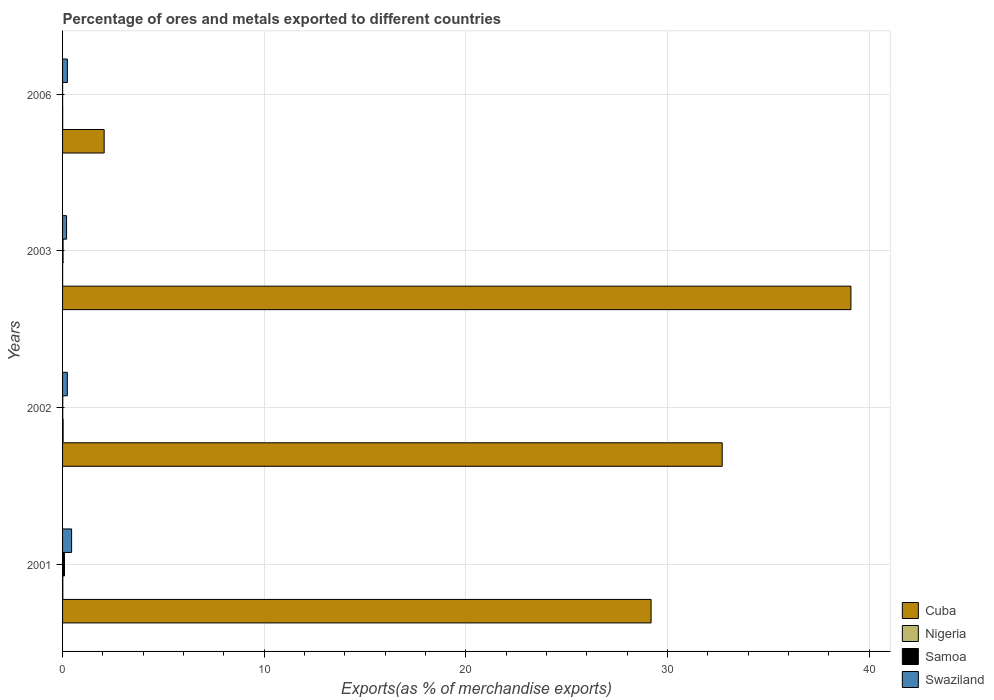How many different coloured bars are there?
Provide a succinct answer. 4. Are the number of bars per tick equal to the number of legend labels?
Your response must be concise. Yes. Are the number of bars on each tick of the Y-axis equal?
Keep it short and to the point. Yes. How many bars are there on the 3rd tick from the top?
Offer a terse response. 4. How many bars are there on the 4th tick from the bottom?
Your answer should be compact. 4. In how many cases, is the number of bars for a given year not equal to the number of legend labels?
Offer a very short reply. 0. What is the percentage of exports to different countries in Cuba in 2006?
Make the answer very short. 2.06. Across all years, what is the maximum percentage of exports to different countries in Nigeria?
Make the answer very short. 0.03. Across all years, what is the minimum percentage of exports to different countries in Nigeria?
Provide a succinct answer. 0. In which year was the percentage of exports to different countries in Nigeria minimum?
Your answer should be compact. 2003. What is the total percentage of exports to different countries in Samoa in the graph?
Make the answer very short. 0.13. What is the difference between the percentage of exports to different countries in Samoa in 2003 and that in 2006?
Offer a very short reply. 0.02. What is the difference between the percentage of exports to different countries in Cuba in 2003 and the percentage of exports to different countries in Samoa in 2002?
Keep it short and to the point. 39.08. What is the average percentage of exports to different countries in Nigeria per year?
Offer a terse response. 0.01. In the year 2006, what is the difference between the percentage of exports to different countries in Swaziland and percentage of exports to different countries in Cuba?
Ensure brevity in your answer.  -1.82. What is the ratio of the percentage of exports to different countries in Cuba in 2001 to that in 2003?
Your answer should be very brief. 0.75. What is the difference between the highest and the second highest percentage of exports to different countries in Swaziland?
Ensure brevity in your answer.  0.21. What is the difference between the highest and the lowest percentage of exports to different countries in Cuba?
Provide a succinct answer. 37.03. In how many years, is the percentage of exports to different countries in Nigeria greater than the average percentage of exports to different countries in Nigeria taken over all years?
Provide a succinct answer. 2. What does the 2nd bar from the top in 2001 represents?
Keep it short and to the point. Samoa. What does the 1st bar from the bottom in 2003 represents?
Your answer should be compact. Cuba. Are all the bars in the graph horizontal?
Your answer should be very brief. Yes. How many years are there in the graph?
Ensure brevity in your answer.  4. Where does the legend appear in the graph?
Your answer should be very brief. Bottom right. How many legend labels are there?
Ensure brevity in your answer.  4. What is the title of the graph?
Give a very brief answer. Percentage of ores and metals exported to different countries. What is the label or title of the X-axis?
Your response must be concise. Exports(as % of merchandise exports). What is the Exports(as % of merchandise exports) in Cuba in 2001?
Ensure brevity in your answer.  29.18. What is the Exports(as % of merchandise exports) in Nigeria in 2001?
Your answer should be compact. 0.01. What is the Exports(as % of merchandise exports) in Samoa in 2001?
Offer a terse response. 0.1. What is the Exports(as % of merchandise exports) in Swaziland in 2001?
Make the answer very short. 0.45. What is the Exports(as % of merchandise exports) of Cuba in 2002?
Offer a very short reply. 32.71. What is the Exports(as % of merchandise exports) of Nigeria in 2002?
Provide a short and direct response. 0.03. What is the Exports(as % of merchandise exports) of Samoa in 2002?
Your response must be concise. 0.01. What is the Exports(as % of merchandise exports) of Swaziland in 2002?
Offer a very short reply. 0.24. What is the Exports(as % of merchandise exports) in Cuba in 2003?
Give a very brief answer. 39.09. What is the Exports(as % of merchandise exports) of Nigeria in 2003?
Your response must be concise. 0. What is the Exports(as % of merchandise exports) of Samoa in 2003?
Keep it short and to the point. 0.02. What is the Exports(as % of merchandise exports) of Swaziland in 2003?
Ensure brevity in your answer.  0.2. What is the Exports(as % of merchandise exports) in Cuba in 2006?
Your answer should be compact. 2.06. What is the Exports(as % of merchandise exports) in Nigeria in 2006?
Give a very brief answer. 0.01. What is the Exports(as % of merchandise exports) of Samoa in 2006?
Make the answer very short. 0. What is the Exports(as % of merchandise exports) of Swaziland in 2006?
Make the answer very short. 0.24. Across all years, what is the maximum Exports(as % of merchandise exports) of Cuba?
Make the answer very short. 39.09. Across all years, what is the maximum Exports(as % of merchandise exports) in Nigeria?
Make the answer very short. 0.03. Across all years, what is the maximum Exports(as % of merchandise exports) of Samoa?
Ensure brevity in your answer.  0.1. Across all years, what is the maximum Exports(as % of merchandise exports) in Swaziland?
Offer a very short reply. 0.45. Across all years, what is the minimum Exports(as % of merchandise exports) of Cuba?
Ensure brevity in your answer.  2.06. Across all years, what is the minimum Exports(as % of merchandise exports) of Nigeria?
Your response must be concise. 0. Across all years, what is the minimum Exports(as % of merchandise exports) in Samoa?
Give a very brief answer. 0. Across all years, what is the minimum Exports(as % of merchandise exports) in Swaziland?
Ensure brevity in your answer.  0.2. What is the total Exports(as % of merchandise exports) of Cuba in the graph?
Provide a succinct answer. 103.05. What is the total Exports(as % of merchandise exports) of Nigeria in the graph?
Your answer should be very brief. 0.05. What is the total Exports(as % of merchandise exports) in Samoa in the graph?
Offer a very short reply. 0.13. What is the total Exports(as % of merchandise exports) in Swaziland in the graph?
Offer a very short reply. 1.12. What is the difference between the Exports(as % of merchandise exports) of Cuba in 2001 and that in 2002?
Offer a terse response. -3.53. What is the difference between the Exports(as % of merchandise exports) in Nigeria in 2001 and that in 2002?
Your answer should be compact. -0.02. What is the difference between the Exports(as % of merchandise exports) in Samoa in 2001 and that in 2002?
Your answer should be compact. 0.09. What is the difference between the Exports(as % of merchandise exports) in Swaziland in 2001 and that in 2002?
Give a very brief answer. 0.21. What is the difference between the Exports(as % of merchandise exports) in Cuba in 2001 and that in 2003?
Offer a very short reply. -9.91. What is the difference between the Exports(as % of merchandise exports) in Nigeria in 2001 and that in 2003?
Give a very brief answer. 0.01. What is the difference between the Exports(as % of merchandise exports) in Samoa in 2001 and that in 2003?
Your response must be concise. 0.07. What is the difference between the Exports(as % of merchandise exports) in Swaziland in 2001 and that in 2003?
Offer a very short reply. 0.25. What is the difference between the Exports(as % of merchandise exports) of Cuba in 2001 and that in 2006?
Ensure brevity in your answer.  27.12. What is the difference between the Exports(as % of merchandise exports) in Nigeria in 2001 and that in 2006?
Make the answer very short. 0.01. What is the difference between the Exports(as % of merchandise exports) in Samoa in 2001 and that in 2006?
Ensure brevity in your answer.  0.09. What is the difference between the Exports(as % of merchandise exports) in Swaziland in 2001 and that in 2006?
Ensure brevity in your answer.  0.21. What is the difference between the Exports(as % of merchandise exports) in Cuba in 2002 and that in 2003?
Offer a terse response. -6.38. What is the difference between the Exports(as % of merchandise exports) of Nigeria in 2002 and that in 2003?
Your answer should be compact. 0.03. What is the difference between the Exports(as % of merchandise exports) of Samoa in 2002 and that in 2003?
Your answer should be compact. -0.02. What is the difference between the Exports(as % of merchandise exports) of Swaziland in 2002 and that in 2003?
Give a very brief answer. 0.04. What is the difference between the Exports(as % of merchandise exports) in Cuba in 2002 and that in 2006?
Provide a short and direct response. 30.65. What is the difference between the Exports(as % of merchandise exports) of Nigeria in 2002 and that in 2006?
Give a very brief answer. 0.02. What is the difference between the Exports(as % of merchandise exports) in Samoa in 2002 and that in 2006?
Your answer should be very brief. 0.01. What is the difference between the Exports(as % of merchandise exports) in Swaziland in 2002 and that in 2006?
Provide a succinct answer. -0. What is the difference between the Exports(as % of merchandise exports) of Cuba in 2003 and that in 2006?
Your answer should be very brief. 37.03. What is the difference between the Exports(as % of merchandise exports) of Nigeria in 2003 and that in 2006?
Make the answer very short. -0. What is the difference between the Exports(as % of merchandise exports) of Samoa in 2003 and that in 2006?
Your answer should be compact. 0.02. What is the difference between the Exports(as % of merchandise exports) in Swaziland in 2003 and that in 2006?
Provide a succinct answer. -0.04. What is the difference between the Exports(as % of merchandise exports) of Cuba in 2001 and the Exports(as % of merchandise exports) of Nigeria in 2002?
Your response must be concise. 29.15. What is the difference between the Exports(as % of merchandise exports) of Cuba in 2001 and the Exports(as % of merchandise exports) of Samoa in 2002?
Your response must be concise. 29.17. What is the difference between the Exports(as % of merchandise exports) of Cuba in 2001 and the Exports(as % of merchandise exports) of Swaziland in 2002?
Give a very brief answer. 28.95. What is the difference between the Exports(as % of merchandise exports) in Nigeria in 2001 and the Exports(as % of merchandise exports) in Samoa in 2002?
Provide a succinct answer. 0. What is the difference between the Exports(as % of merchandise exports) in Nigeria in 2001 and the Exports(as % of merchandise exports) in Swaziland in 2002?
Your answer should be very brief. -0.22. What is the difference between the Exports(as % of merchandise exports) in Samoa in 2001 and the Exports(as % of merchandise exports) in Swaziland in 2002?
Give a very brief answer. -0.14. What is the difference between the Exports(as % of merchandise exports) in Cuba in 2001 and the Exports(as % of merchandise exports) in Nigeria in 2003?
Offer a terse response. 29.18. What is the difference between the Exports(as % of merchandise exports) of Cuba in 2001 and the Exports(as % of merchandise exports) of Samoa in 2003?
Ensure brevity in your answer.  29.16. What is the difference between the Exports(as % of merchandise exports) of Cuba in 2001 and the Exports(as % of merchandise exports) of Swaziland in 2003?
Provide a succinct answer. 28.98. What is the difference between the Exports(as % of merchandise exports) of Nigeria in 2001 and the Exports(as % of merchandise exports) of Samoa in 2003?
Provide a succinct answer. -0.01. What is the difference between the Exports(as % of merchandise exports) in Nigeria in 2001 and the Exports(as % of merchandise exports) in Swaziland in 2003?
Offer a terse response. -0.19. What is the difference between the Exports(as % of merchandise exports) of Samoa in 2001 and the Exports(as % of merchandise exports) of Swaziland in 2003?
Offer a very short reply. -0.1. What is the difference between the Exports(as % of merchandise exports) in Cuba in 2001 and the Exports(as % of merchandise exports) in Nigeria in 2006?
Make the answer very short. 29.18. What is the difference between the Exports(as % of merchandise exports) in Cuba in 2001 and the Exports(as % of merchandise exports) in Samoa in 2006?
Your answer should be very brief. 29.18. What is the difference between the Exports(as % of merchandise exports) of Cuba in 2001 and the Exports(as % of merchandise exports) of Swaziland in 2006?
Give a very brief answer. 28.94. What is the difference between the Exports(as % of merchandise exports) in Nigeria in 2001 and the Exports(as % of merchandise exports) in Samoa in 2006?
Your answer should be very brief. 0.01. What is the difference between the Exports(as % of merchandise exports) in Nigeria in 2001 and the Exports(as % of merchandise exports) in Swaziland in 2006?
Your answer should be very brief. -0.23. What is the difference between the Exports(as % of merchandise exports) of Samoa in 2001 and the Exports(as % of merchandise exports) of Swaziland in 2006?
Keep it short and to the point. -0.14. What is the difference between the Exports(as % of merchandise exports) of Cuba in 2002 and the Exports(as % of merchandise exports) of Nigeria in 2003?
Your response must be concise. 32.71. What is the difference between the Exports(as % of merchandise exports) of Cuba in 2002 and the Exports(as % of merchandise exports) of Samoa in 2003?
Give a very brief answer. 32.68. What is the difference between the Exports(as % of merchandise exports) in Cuba in 2002 and the Exports(as % of merchandise exports) in Swaziland in 2003?
Make the answer very short. 32.51. What is the difference between the Exports(as % of merchandise exports) in Nigeria in 2002 and the Exports(as % of merchandise exports) in Samoa in 2003?
Offer a terse response. 0. What is the difference between the Exports(as % of merchandise exports) of Nigeria in 2002 and the Exports(as % of merchandise exports) of Swaziland in 2003?
Your answer should be very brief. -0.17. What is the difference between the Exports(as % of merchandise exports) of Samoa in 2002 and the Exports(as % of merchandise exports) of Swaziland in 2003?
Ensure brevity in your answer.  -0.19. What is the difference between the Exports(as % of merchandise exports) of Cuba in 2002 and the Exports(as % of merchandise exports) of Nigeria in 2006?
Offer a very short reply. 32.7. What is the difference between the Exports(as % of merchandise exports) of Cuba in 2002 and the Exports(as % of merchandise exports) of Samoa in 2006?
Your response must be concise. 32.71. What is the difference between the Exports(as % of merchandise exports) of Cuba in 2002 and the Exports(as % of merchandise exports) of Swaziland in 2006?
Provide a short and direct response. 32.47. What is the difference between the Exports(as % of merchandise exports) in Nigeria in 2002 and the Exports(as % of merchandise exports) in Samoa in 2006?
Your response must be concise. 0.03. What is the difference between the Exports(as % of merchandise exports) in Nigeria in 2002 and the Exports(as % of merchandise exports) in Swaziland in 2006?
Offer a terse response. -0.21. What is the difference between the Exports(as % of merchandise exports) in Samoa in 2002 and the Exports(as % of merchandise exports) in Swaziland in 2006?
Your response must be concise. -0.23. What is the difference between the Exports(as % of merchandise exports) of Cuba in 2003 and the Exports(as % of merchandise exports) of Nigeria in 2006?
Give a very brief answer. 39.09. What is the difference between the Exports(as % of merchandise exports) in Cuba in 2003 and the Exports(as % of merchandise exports) in Samoa in 2006?
Ensure brevity in your answer.  39.09. What is the difference between the Exports(as % of merchandise exports) of Cuba in 2003 and the Exports(as % of merchandise exports) of Swaziland in 2006?
Offer a terse response. 38.85. What is the difference between the Exports(as % of merchandise exports) in Nigeria in 2003 and the Exports(as % of merchandise exports) in Samoa in 2006?
Provide a short and direct response. 0. What is the difference between the Exports(as % of merchandise exports) in Nigeria in 2003 and the Exports(as % of merchandise exports) in Swaziland in 2006?
Keep it short and to the point. -0.24. What is the difference between the Exports(as % of merchandise exports) of Samoa in 2003 and the Exports(as % of merchandise exports) of Swaziland in 2006?
Provide a short and direct response. -0.21. What is the average Exports(as % of merchandise exports) in Cuba per year?
Provide a succinct answer. 25.76. What is the average Exports(as % of merchandise exports) of Nigeria per year?
Offer a terse response. 0.01. What is the average Exports(as % of merchandise exports) of Samoa per year?
Ensure brevity in your answer.  0.03. What is the average Exports(as % of merchandise exports) of Swaziland per year?
Make the answer very short. 0.28. In the year 2001, what is the difference between the Exports(as % of merchandise exports) of Cuba and Exports(as % of merchandise exports) of Nigeria?
Your answer should be very brief. 29.17. In the year 2001, what is the difference between the Exports(as % of merchandise exports) of Cuba and Exports(as % of merchandise exports) of Samoa?
Make the answer very short. 29.09. In the year 2001, what is the difference between the Exports(as % of merchandise exports) of Cuba and Exports(as % of merchandise exports) of Swaziland?
Provide a short and direct response. 28.73. In the year 2001, what is the difference between the Exports(as % of merchandise exports) in Nigeria and Exports(as % of merchandise exports) in Samoa?
Your response must be concise. -0.08. In the year 2001, what is the difference between the Exports(as % of merchandise exports) of Nigeria and Exports(as % of merchandise exports) of Swaziland?
Provide a succinct answer. -0.44. In the year 2001, what is the difference between the Exports(as % of merchandise exports) of Samoa and Exports(as % of merchandise exports) of Swaziland?
Your answer should be compact. -0.35. In the year 2002, what is the difference between the Exports(as % of merchandise exports) of Cuba and Exports(as % of merchandise exports) of Nigeria?
Ensure brevity in your answer.  32.68. In the year 2002, what is the difference between the Exports(as % of merchandise exports) of Cuba and Exports(as % of merchandise exports) of Samoa?
Offer a terse response. 32.7. In the year 2002, what is the difference between the Exports(as % of merchandise exports) in Cuba and Exports(as % of merchandise exports) in Swaziland?
Your response must be concise. 32.47. In the year 2002, what is the difference between the Exports(as % of merchandise exports) of Nigeria and Exports(as % of merchandise exports) of Samoa?
Ensure brevity in your answer.  0.02. In the year 2002, what is the difference between the Exports(as % of merchandise exports) of Nigeria and Exports(as % of merchandise exports) of Swaziland?
Your response must be concise. -0.21. In the year 2002, what is the difference between the Exports(as % of merchandise exports) of Samoa and Exports(as % of merchandise exports) of Swaziland?
Ensure brevity in your answer.  -0.23. In the year 2003, what is the difference between the Exports(as % of merchandise exports) in Cuba and Exports(as % of merchandise exports) in Nigeria?
Your response must be concise. 39.09. In the year 2003, what is the difference between the Exports(as % of merchandise exports) in Cuba and Exports(as % of merchandise exports) in Samoa?
Keep it short and to the point. 39.07. In the year 2003, what is the difference between the Exports(as % of merchandise exports) of Cuba and Exports(as % of merchandise exports) of Swaziland?
Offer a terse response. 38.89. In the year 2003, what is the difference between the Exports(as % of merchandise exports) in Nigeria and Exports(as % of merchandise exports) in Samoa?
Make the answer very short. -0.02. In the year 2003, what is the difference between the Exports(as % of merchandise exports) of Nigeria and Exports(as % of merchandise exports) of Swaziland?
Offer a very short reply. -0.2. In the year 2003, what is the difference between the Exports(as % of merchandise exports) in Samoa and Exports(as % of merchandise exports) in Swaziland?
Provide a short and direct response. -0.17. In the year 2006, what is the difference between the Exports(as % of merchandise exports) of Cuba and Exports(as % of merchandise exports) of Nigeria?
Ensure brevity in your answer.  2.06. In the year 2006, what is the difference between the Exports(as % of merchandise exports) in Cuba and Exports(as % of merchandise exports) in Samoa?
Give a very brief answer. 2.06. In the year 2006, what is the difference between the Exports(as % of merchandise exports) of Cuba and Exports(as % of merchandise exports) of Swaziland?
Offer a terse response. 1.82. In the year 2006, what is the difference between the Exports(as % of merchandise exports) in Nigeria and Exports(as % of merchandise exports) in Samoa?
Ensure brevity in your answer.  0. In the year 2006, what is the difference between the Exports(as % of merchandise exports) in Nigeria and Exports(as % of merchandise exports) in Swaziland?
Give a very brief answer. -0.23. In the year 2006, what is the difference between the Exports(as % of merchandise exports) of Samoa and Exports(as % of merchandise exports) of Swaziland?
Your answer should be compact. -0.24. What is the ratio of the Exports(as % of merchandise exports) of Cuba in 2001 to that in 2002?
Provide a succinct answer. 0.89. What is the ratio of the Exports(as % of merchandise exports) in Nigeria in 2001 to that in 2002?
Provide a succinct answer. 0.45. What is the ratio of the Exports(as % of merchandise exports) in Samoa in 2001 to that in 2002?
Your answer should be very brief. 10.1. What is the ratio of the Exports(as % of merchandise exports) of Swaziland in 2001 to that in 2002?
Give a very brief answer. 1.9. What is the ratio of the Exports(as % of merchandise exports) in Cuba in 2001 to that in 2003?
Your response must be concise. 0.75. What is the ratio of the Exports(as % of merchandise exports) in Nigeria in 2001 to that in 2003?
Offer a terse response. 4.49. What is the ratio of the Exports(as % of merchandise exports) of Samoa in 2001 to that in 2003?
Your answer should be very brief. 3.87. What is the ratio of the Exports(as % of merchandise exports) in Swaziland in 2001 to that in 2003?
Make the answer very short. 2.26. What is the ratio of the Exports(as % of merchandise exports) in Cuba in 2001 to that in 2006?
Provide a short and direct response. 14.15. What is the ratio of the Exports(as % of merchandise exports) in Nigeria in 2001 to that in 2006?
Keep it short and to the point. 2.22. What is the ratio of the Exports(as % of merchandise exports) of Samoa in 2001 to that in 2006?
Keep it short and to the point. 46.72. What is the ratio of the Exports(as % of merchandise exports) in Swaziland in 2001 to that in 2006?
Your answer should be very brief. 1.88. What is the ratio of the Exports(as % of merchandise exports) of Cuba in 2002 to that in 2003?
Your answer should be compact. 0.84. What is the ratio of the Exports(as % of merchandise exports) in Nigeria in 2002 to that in 2003?
Make the answer very short. 10.03. What is the ratio of the Exports(as % of merchandise exports) in Samoa in 2002 to that in 2003?
Offer a very short reply. 0.38. What is the ratio of the Exports(as % of merchandise exports) of Swaziland in 2002 to that in 2003?
Give a very brief answer. 1.19. What is the ratio of the Exports(as % of merchandise exports) of Cuba in 2002 to that in 2006?
Your answer should be very brief. 15.86. What is the ratio of the Exports(as % of merchandise exports) in Nigeria in 2002 to that in 2006?
Offer a terse response. 4.96. What is the ratio of the Exports(as % of merchandise exports) in Samoa in 2002 to that in 2006?
Your response must be concise. 4.63. What is the ratio of the Exports(as % of merchandise exports) in Swaziland in 2002 to that in 2006?
Make the answer very short. 0.99. What is the ratio of the Exports(as % of merchandise exports) of Cuba in 2003 to that in 2006?
Your answer should be very brief. 18.96. What is the ratio of the Exports(as % of merchandise exports) in Nigeria in 2003 to that in 2006?
Keep it short and to the point. 0.49. What is the ratio of the Exports(as % of merchandise exports) of Samoa in 2003 to that in 2006?
Offer a terse response. 12.09. What is the ratio of the Exports(as % of merchandise exports) of Swaziland in 2003 to that in 2006?
Provide a short and direct response. 0.83. What is the difference between the highest and the second highest Exports(as % of merchandise exports) of Cuba?
Make the answer very short. 6.38. What is the difference between the highest and the second highest Exports(as % of merchandise exports) of Nigeria?
Make the answer very short. 0.02. What is the difference between the highest and the second highest Exports(as % of merchandise exports) in Samoa?
Make the answer very short. 0.07. What is the difference between the highest and the second highest Exports(as % of merchandise exports) of Swaziland?
Your answer should be compact. 0.21. What is the difference between the highest and the lowest Exports(as % of merchandise exports) of Cuba?
Your response must be concise. 37.03. What is the difference between the highest and the lowest Exports(as % of merchandise exports) of Nigeria?
Keep it short and to the point. 0.03. What is the difference between the highest and the lowest Exports(as % of merchandise exports) of Samoa?
Provide a succinct answer. 0.09. What is the difference between the highest and the lowest Exports(as % of merchandise exports) in Swaziland?
Your answer should be compact. 0.25. 